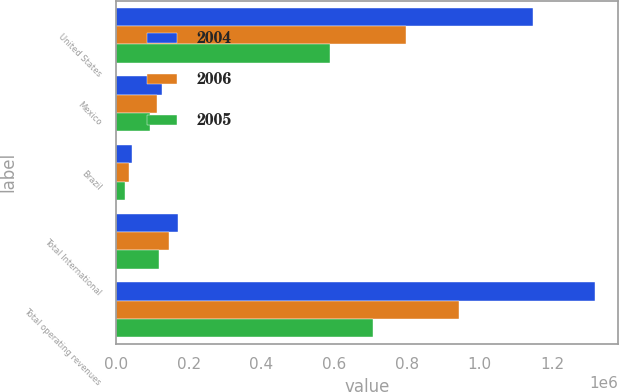Convert chart. <chart><loc_0><loc_0><loc_500><loc_500><stacked_bar_chart><ecel><fcel>United States<fcel>Mexico<fcel>Brazil<fcel>Total International<fcel>Total operating revenues<nl><fcel>2004<fcel>1.14779e+06<fcel>125694<fcel>43904<fcel>169598<fcel>1.31738e+06<nl><fcel>2006<fcel>798010<fcel>111421<fcel>35355<fcel>146776<fcel>944786<nl><fcel>2005<fcel>589395<fcel>93186<fcel>24079<fcel>117265<fcel>706660<nl></chart> 